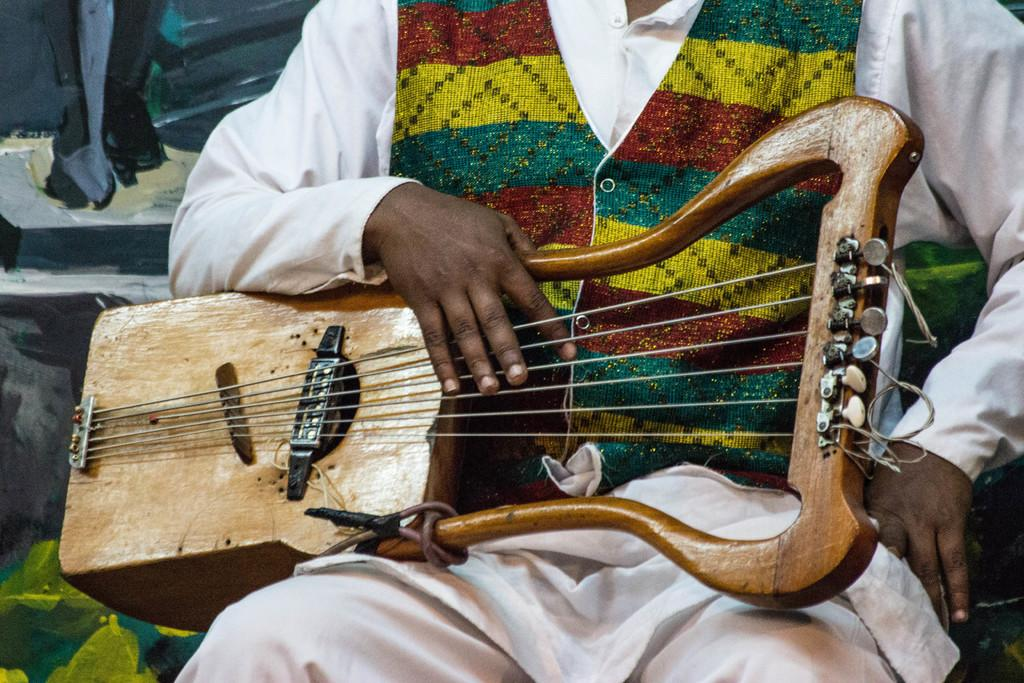What is the primary subject of the image? There is a human in the image. What is the human doing in the image? The human is seated and playing a musical instrument. How many toes can be seen on the human's feet in the image? There is no information about the human's toes in the image, so it cannot be determined. 